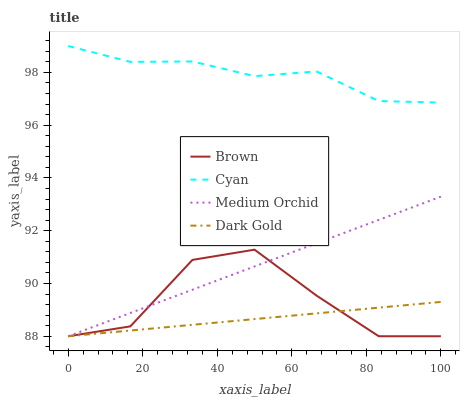Does Dark Gold have the minimum area under the curve?
Answer yes or no. Yes. Does Cyan have the maximum area under the curve?
Answer yes or no. Yes. Does Medium Orchid have the minimum area under the curve?
Answer yes or no. No. Does Medium Orchid have the maximum area under the curve?
Answer yes or no. No. Is Dark Gold the smoothest?
Answer yes or no. Yes. Is Brown the roughest?
Answer yes or no. Yes. Is Medium Orchid the smoothest?
Answer yes or no. No. Is Medium Orchid the roughest?
Answer yes or no. No. Does Brown have the lowest value?
Answer yes or no. Yes. Does Cyan have the lowest value?
Answer yes or no. No. Does Cyan have the highest value?
Answer yes or no. Yes. Does Medium Orchid have the highest value?
Answer yes or no. No. Is Brown less than Cyan?
Answer yes or no. Yes. Is Cyan greater than Dark Gold?
Answer yes or no. Yes. Does Dark Gold intersect Brown?
Answer yes or no. Yes. Is Dark Gold less than Brown?
Answer yes or no. No. Is Dark Gold greater than Brown?
Answer yes or no. No. Does Brown intersect Cyan?
Answer yes or no. No. 